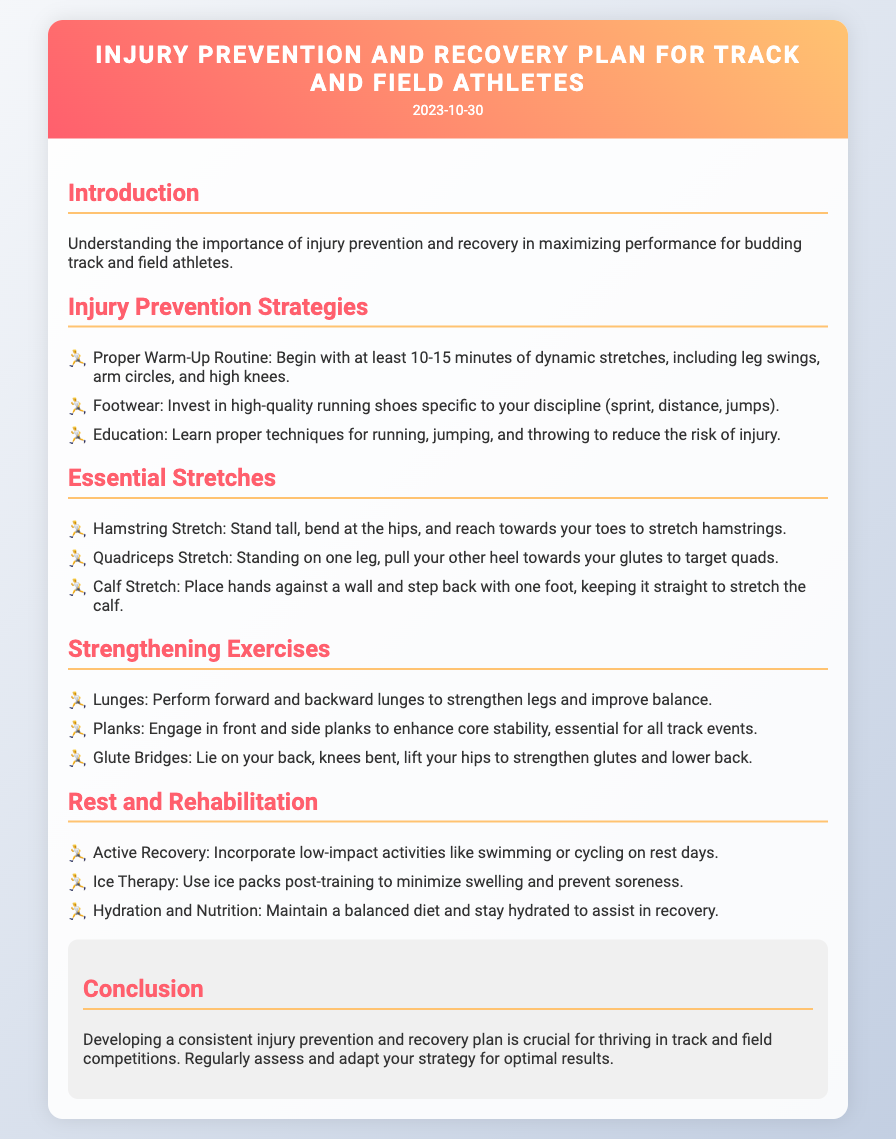What is the title of the document? The title of the document is found in the header section, representing the main topic of the content.
Answer: Injury Prevention and Recovery Plan for Track and Field Athletes What is the date of the document? The date is located just below the title and indicates when the document was created or last updated.
Answer: 2023-10-30 How long should the warm-up routine be? The duration of the warm-up routine is specified in the section detailing injury prevention strategies.
Answer: 10-15 minutes Which stretch targets the hamstrings? The document lists various essential stretches, and one specifically mentions targeting the hamstrings.
Answer: Hamstring Stretch What type of exercise is mentioned for core stability? The strengthening exercises section includes types of exercises, one of which focuses on core stability.
Answer: Planks Which activity is recommended for active recovery? The rest and rehabilitation section provides options for low-impact activities to engage in on rest days.
Answer: Swimming What should be used post-training to minimize swelling? The document specifies a therapy method in the rest and rehabilitation section to address swelling after training.
Answer: Ice Therapy What is crucial for thriving in track and field competitions? The conclusion highlights an important aspect for success in sports, summarizing the key strategy discussed in the document.
Answer: Consistent injury prevention and recovery plan How many stretching exercises are mentioned? The list in the essential stretches section provides the number of different stretches included.
Answer: Three 